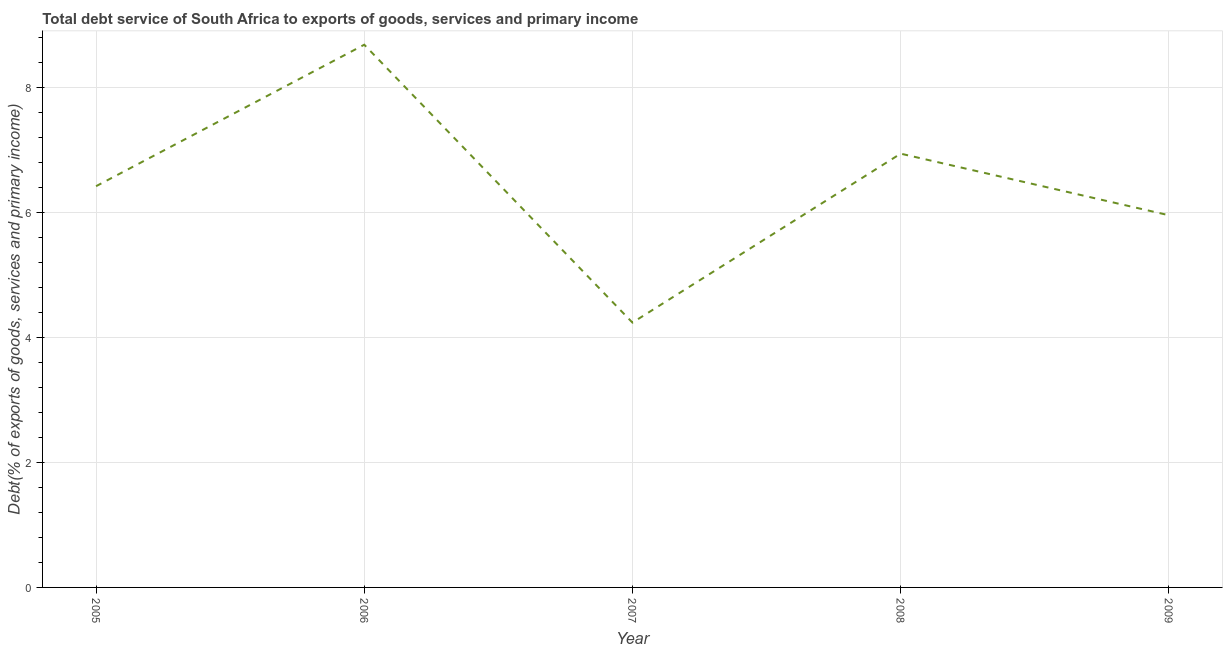What is the total debt service in 2007?
Keep it short and to the point. 4.24. Across all years, what is the maximum total debt service?
Ensure brevity in your answer.  8.68. Across all years, what is the minimum total debt service?
Provide a short and direct response. 4.24. In which year was the total debt service maximum?
Your answer should be compact. 2006. What is the sum of the total debt service?
Give a very brief answer. 32.22. What is the difference between the total debt service in 2005 and 2008?
Provide a short and direct response. -0.52. What is the average total debt service per year?
Offer a very short reply. 6.44. What is the median total debt service?
Keep it short and to the point. 6.42. What is the ratio of the total debt service in 2007 to that in 2009?
Offer a terse response. 0.71. Is the difference between the total debt service in 2007 and 2008 greater than the difference between any two years?
Make the answer very short. No. What is the difference between the highest and the second highest total debt service?
Provide a short and direct response. 1.74. What is the difference between the highest and the lowest total debt service?
Ensure brevity in your answer.  4.44. In how many years, is the total debt service greater than the average total debt service taken over all years?
Your response must be concise. 2. Does the total debt service monotonically increase over the years?
Offer a terse response. No. How many years are there in the graph?
Ensure brevity in your answer.  5. What is the difference between two consecutive major ticks on the Y-axis?
Your answer should be very brief. 2. Does the graph contain any zero values?
Keep it short and to the point. No. Does the graph contain grids?
Give a very brief answer. Yes. What is the title of the graph?
Keep it short and to the point. Total debt service of South Africa to exports of goods, services and primary income. What is the label or title of the X-axis?
Your answer should be compact. Year. What is the label or title of the Y-axis?
Provide a succinct answer. Debt(% of exports of goods, services and primary income). What is the Debt(% of exports of goods, services and primary income) in 2005?
Provide a short and direct response. 6.42. What is the Debt(% of exports of goods, services and primary income) in 2006?
Make the answer very short. 8.68. What is the Debt(% of exports of goods, services and primary income) of 2007?
Provide a short and direct response. 4.24. What is the Debt(% of exports of goods, services and primary income) in 2008?
Your response must be concise. 6.94. What is the Debt(% of exports of goods, services and primary income) of 2009?
Your answer should be compact. 5.95. What is the difference between the Debt(% of exports of goods, services and primary income) in 2005 and 2006?
Keep it short and to the point. -2.26. What is the difference between the Debt(% of exports of goods, services and primary income) in 2005 and 2007?
Provide a short and direct response. 2.18. What is the difference between the Debt(% of exports of goods, services and primary income) in 2005 and 2008?
Make the answer very short. -0.52. What is the difference between the Debt(% of exports of goods, services and primary income) in 2005 and 2009?
Ensure brevity in your answer.  0.46. What is the difference between the Debt(% of exports of goods, services and primary income) in 2006 and 2007?
Provide a short and direct response. 4.44. What is the difference between the Debt(% of exports of goods, services and primary income) in 2006 and 2008?
Offer a terse response. 1.74. What is the difference between the Debt(% of exports of goods, services and primary income) in 2006 and 2009?
Your answer should be very brief. 2.73. What is the difference between the Debt(% of exports of goods, services and primary income) in 2007 and 2008?
Provide a succinct answer. -2.7. What is the difference between the Debt(% of exports of goods, services and primary income) in 2007 and 2009?
Keep it short and to the point. -1.72. What is the difference between the Debt(% of exports of goods, services and primary income) in 2008 and 2009?
Provide a succinct answer. 0.98. What is the ratio of the Debt(% of exports of goods, services and primary income) in 2005 to that in 2006?
Give a very brief answer. 0.74. What is the ratio of the Debt(% of exports of goods, services and primary income) in 2005 to that in 2007?
Ensure brevity in your answer.  1.51. What is the ratio of the Debt(% of exports of goods, services and primary income) in 2005 to that in 2008?
Offer a terse response. 0.93. What is the ratio of the Debt(% of exports of goods, services and primary income) in 2005 to that in 2009?
Offer a terse response. 1.08. What is the ratio of the Debt(% of exports of goods, services and primary income) in 2006 to that in 2007?
Provide a succinct answer. 2.05. What is the ratio of the Debt(% of exports of goods, services and primary income) in 2006 to that in 2008?
Your response must be concise. 1.25. What is the ratio of the Debt(% of exports of goods, services and primary income) in 2006 to that in 2009?
Ensure brevity in your answer.  1.46. What is the ratio of the Debt(% of exports of goods, services and primary income) in 2007 to that in 2008?
Offer a very short reply. 0.61. What is the ratio of the Debt(% of exports of goods, services and primary income) in 2007 to that in 2009?
Offer a terse response. 0.71. What is the ratio of the Debt(% of exports of goods, services and primary income) in 2008 to that in 2009?
Offer a terse response. 1.17. 